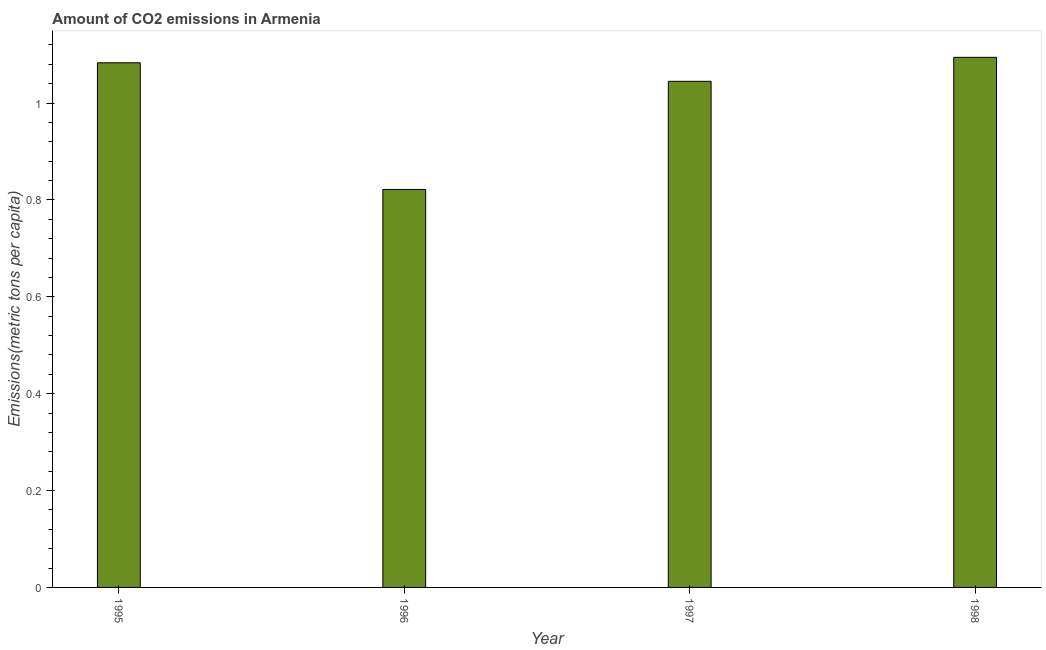Does the graph contain grids?
Provide a succinct answer. No. What is the title of the graph?
Offer a very short reply. Amount of CO2 emissions in Armenia. What is the label or title of the X-axis?
Provide a short and direct response. Year. What is the label or title of the Y-axis?
Keep it short and to the point. Emissions(metric tons per capita). What is the amount of co2 emissions in 1997?
Keep it short and to the point. 1.04. Across all years, what is the maximum amount of co2 emissions?
Your answer should be compact. 1.09. Across all years, what is the minimum amount of co2 emissions?
Your response must be concise. 0.82. What is the sum of the amount of co2 emissions?
Ensure brevity in your answer.  4.04. What is the difference between the amount of co2 emissions in 1995 and 1998?
Give a very brief answer. -0.01. What is the median amount of co2 emissions?
Make the answer very short. 1.06. In how many years, is the amount of co2 emissions greater than 0.36 metric tons per capita?
Make the answer very short. 4. Is the amount of co2 emissions in 1996 less than that in 1997?
Offer a terse response. Yes. What is the difference between the highest and the second highest amount of co2 emissions?
Offer a terse response. 0.01. What is the difference between the highest and the lowest amount of co2 emissions?
Your answer should be very brief. 0.27. How many bars are there?
Give a very brief answer. 4. Are all the bars in the graph horizontal?
Your answer should be very brief. No. How many years are there in the graph?
Provide a short and direct response. 4. What is the Emissions(metric tons per capita) of 1995?
Give a very brief answer. 1.08. What is the Emissions(metric tons per capita) in 1996?
Offer a terse response. 0.82. What is the Emissions(metric tons per capita) in 1997?
Your answer should be compact. 1.04. What is the Emissions(metric tons per capita) in 1998?
Your answer should be compact. 1.09. What is the difference between the Emissions(metric tons per capita) in 1995 and 1996?
Give a very brief answer. 0.26. What is the difference between the Emissions(metric tons per capita) in 1995 and 1997?
Offer a terse response. 0.04. What is the difference between the Emissions(metric tons per capita) in 1995 and 1998?
Provide a short and direct response. -0.01. What is the difference between the Emissions(metric tons per capita) in 1996 and 1997?
Your response must be concise. -0.22. What is the difference between the Emissions(metric tons per capita) in 1996 and 1998?
Your response must be concise. -0.27. What is the difference between the Emissions(metric tons per capita) in 1997 and 1998?
Provide a succinct answer. -0.05. What is the ratio of the Emissions(metric tons per capita) in 1995 to that in 1996?
Make the answer very short. 1.32. What is the ratio of the Emissions(metric tons per capita) in 1995 to that in 1997?
Ensure brevity in your answer.  1.04. What is the ratio of the Emissions(metric tons per capita) in 1996 to that in 1997?
Provide a succinct answer. 0.79. What is the ratio of the Emissions(metric tons per capita) in 1996 to that in 1998?
Make the answer very short. 0.75. What is the ratio of the Emissions(metric tons per capita) in 1997 to that in 1998?
Keep it short and to the point. 0.95. 